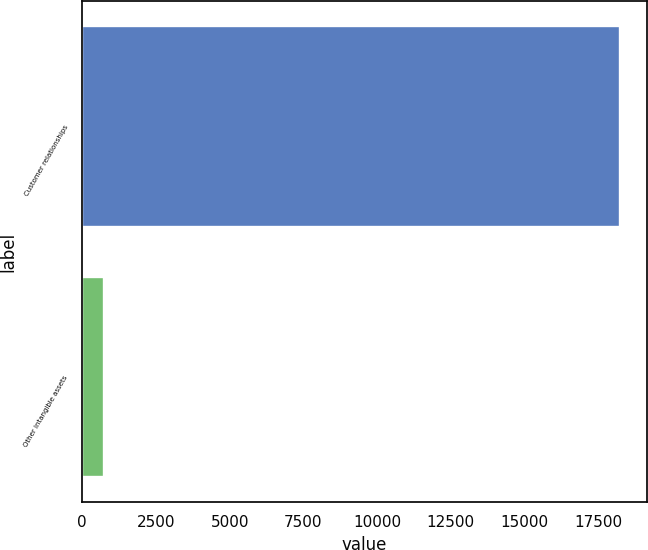Convert chart. <chart><loc_0><loc_0><loc_500><loc_500><bar_chart><fcel>Customer relationships<fcel>Other intangible assets<nl><fcel>18229<fcel>731<nl></chart> 